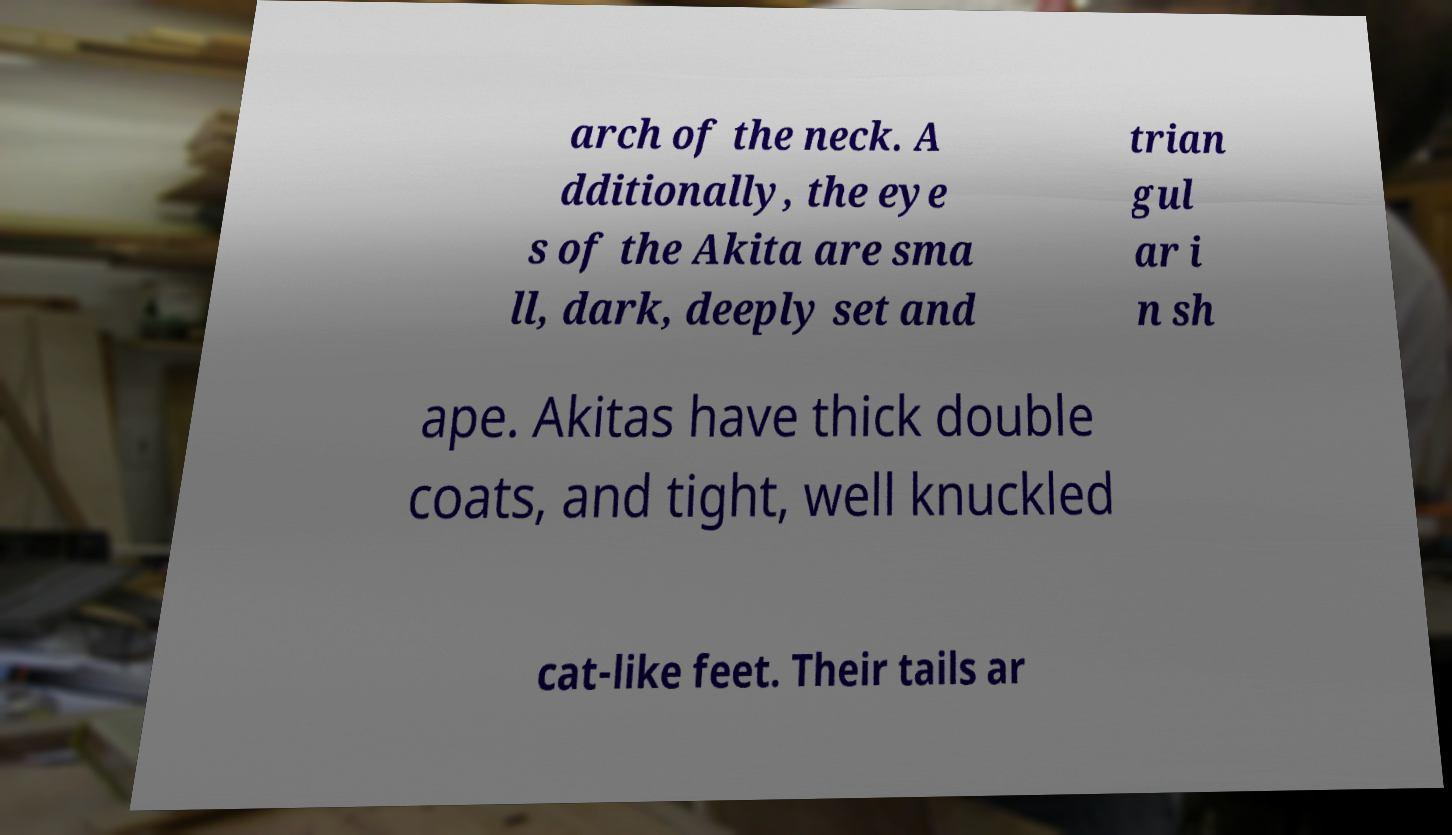Can you accurately transcribe the text from the provided image for me? arch of the neck. A dditionally, the eye s of the Akita are sma ll, dark, deeply set and trian gul ar i n sh ape. Akitas have thick double coats, and tight, well knuckled cat-like feet. Their tails ar 